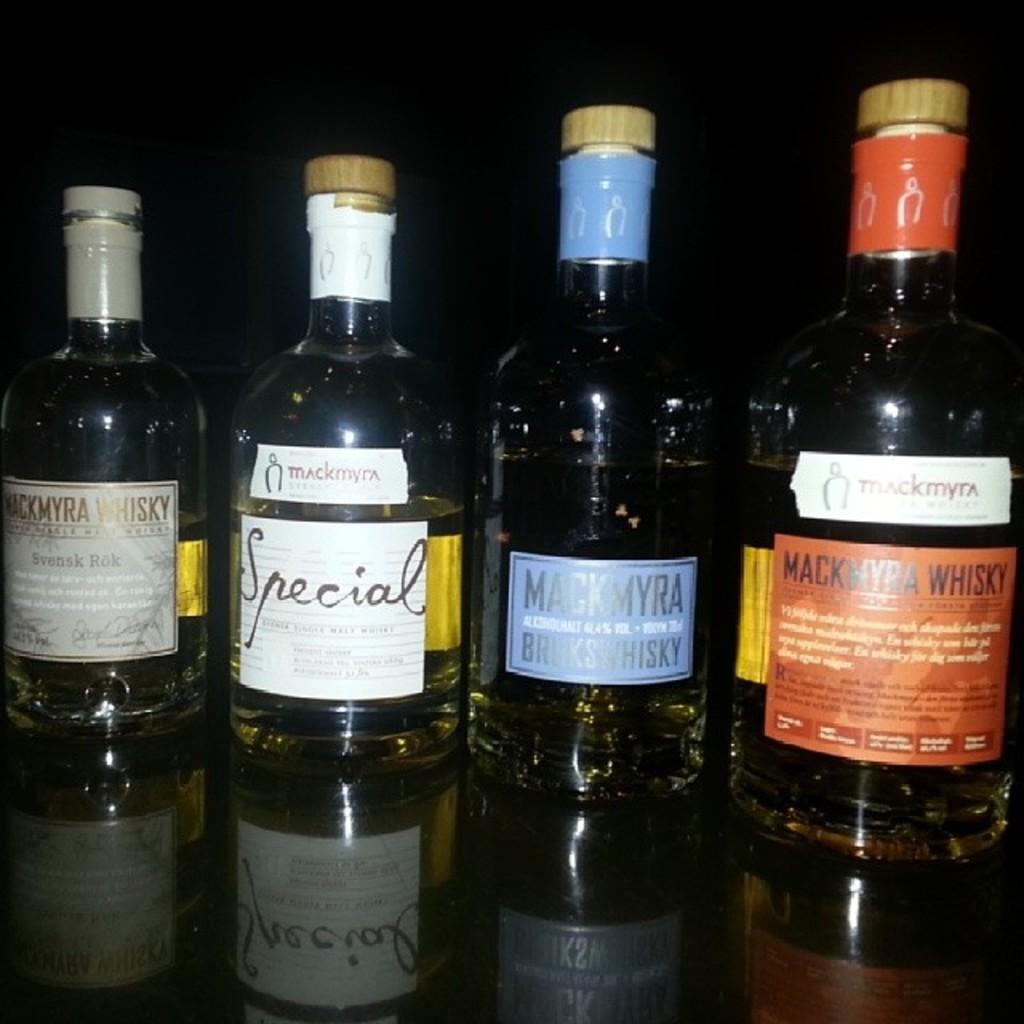Provide a one-sentence caption for the provided image. a few wine bottles and one that had special written on it. 